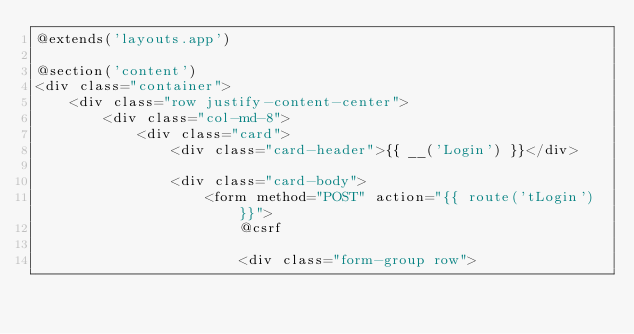<code> <loc_0><loc_0><loc_500><loc_500><_PHP_>@extends('layouts.app')

@section('content')
<div class="container">
    <div class="row justify-content-center">
        <div class="col-md-8">
            <div class="card">
                <div class="card-header">{{ __('Login') }}</div>

                <div class="card-body">
                    <form method="POST" action="{{ route('tLogin') }}">
                        @csrf

                        <div class="form-group row"></code> 